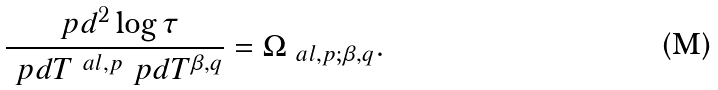<formula> <loc_0><loc_0><loc_500><loc_500>\frac { \ p d ^ { 2 } \log \tau } { \ p d T ^ { \ a l , p } \ p d T ^ { \beta , q } } = \Omega _ { \ a l , p ; \beta , q } .</formula> 